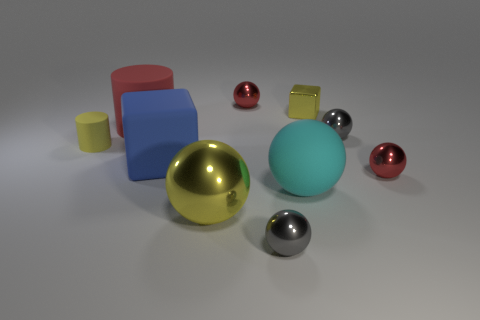Subtract all red metal balls. How many balls are left? 4 Subtract all red cylinders. How many cylinders are left? 1 Subtract 1 cubes. How many cubes are left? 1 Subtract all cylinders. How many objects are left? 8 Subtract 0 cyan cylinders. How many objects are left? 10 Subtract all yellow balls. Subtract all red cylinders. How many balls are left? 5 Subtract all gray blocks. How many green spheres are left? 0 Subtract all shiny things. Subtract all gray metallic objects. How many objects are left? 2 Add 5 small yellow things. How many small yellow things are left? 7 Add 9 red rubber cubes. How many red rubber cubes exist? 9 